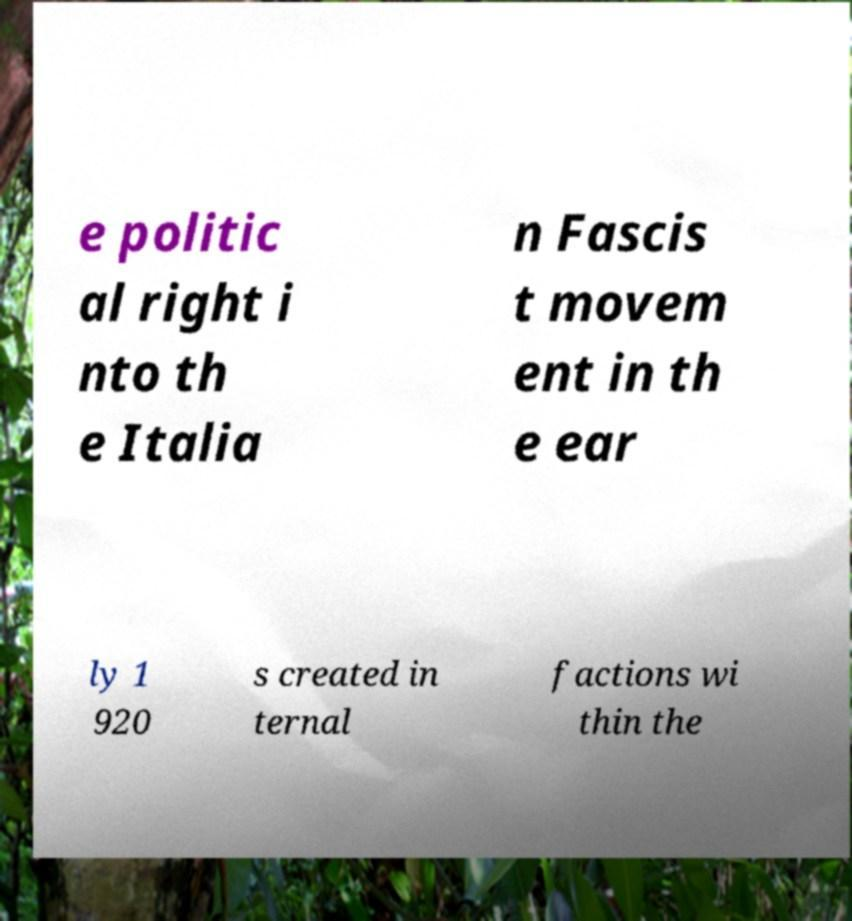Please read and relay the text visible in this image. What does it say? e politic al right i nto th e Italia n Fascis t movem ent in th e ear ly 1 920 s created in ternal factions wi thin the 